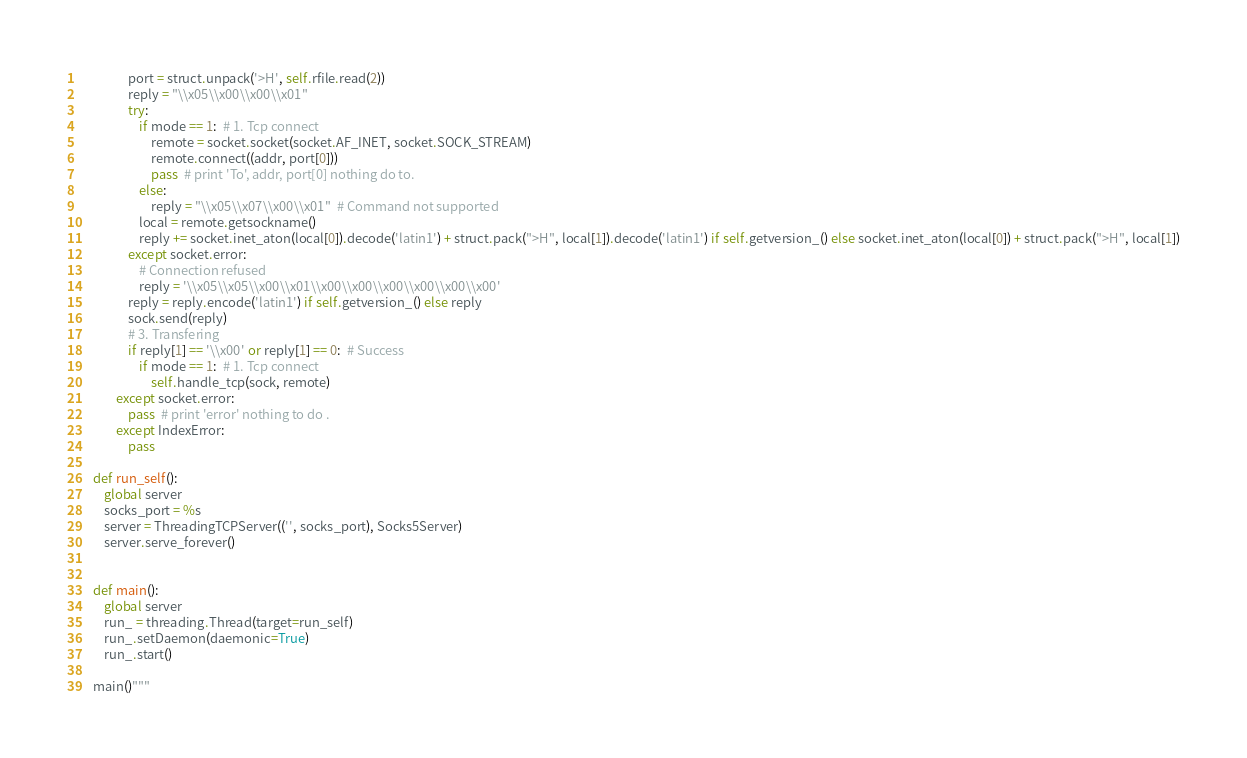Convert code to text. <code><loc_0><loc_0><loc_500><loc_500><_Python_>                port = struct.unpack('>H', self.rfile.read(2))
                reply = "\\x05\\x00\\x00\\x01"
                try:
                    if mode == 1:  # 1. Tcp connect
                        remote = socket.socket(socket.AF_INET, socket.SOCK_STREAM)
                        remote.connect((addr, port[0]))
                        pass  # print 'To', addr, port[0] nothing do to.
                    else:
                        reply = "\\x05\\x07\\x00\\x01"  # Command not supported
                    local = remote.getsockname()
                    reply += socket.inet_aton(local[0]).decode('latin1') + struct.pack(">H", local[1]).decode('latin1') if self.getversion_() else socket.inet_aton(local[0]) + struct.pack(">H", local[1])
                except socket.error:
                    # Connection refused
                    reply = '\\x05\\x05\\x00\\x01\\x00\\x00\\x00\\x00\\x00\\x00'
                reply = reply.encode('latin1') if self.getversion_() else reply
                sock.send(reply)
                # 3. Transfering
                if reply[1] == '\\x00' or reply[1] == 0:  # Success
                    if mode == 1:  # 1. Tcp connect
                        self.handle_tcp(sock, remote)
            except socket.error:
                pass  # print 'error' nothing to do .
            except IndexError:
                pass

    def run_self():
        global server
        socks_port = %s
        server = ThreadingTCPServer(('', socks_port), Socks5Server)
        server.serve_forever()


    def main():
        global server
        run_ = threading.Thread(target=run_self)
        run_.setDaemon(daemonic=True)
        run_.start()

    main()"""</code> 